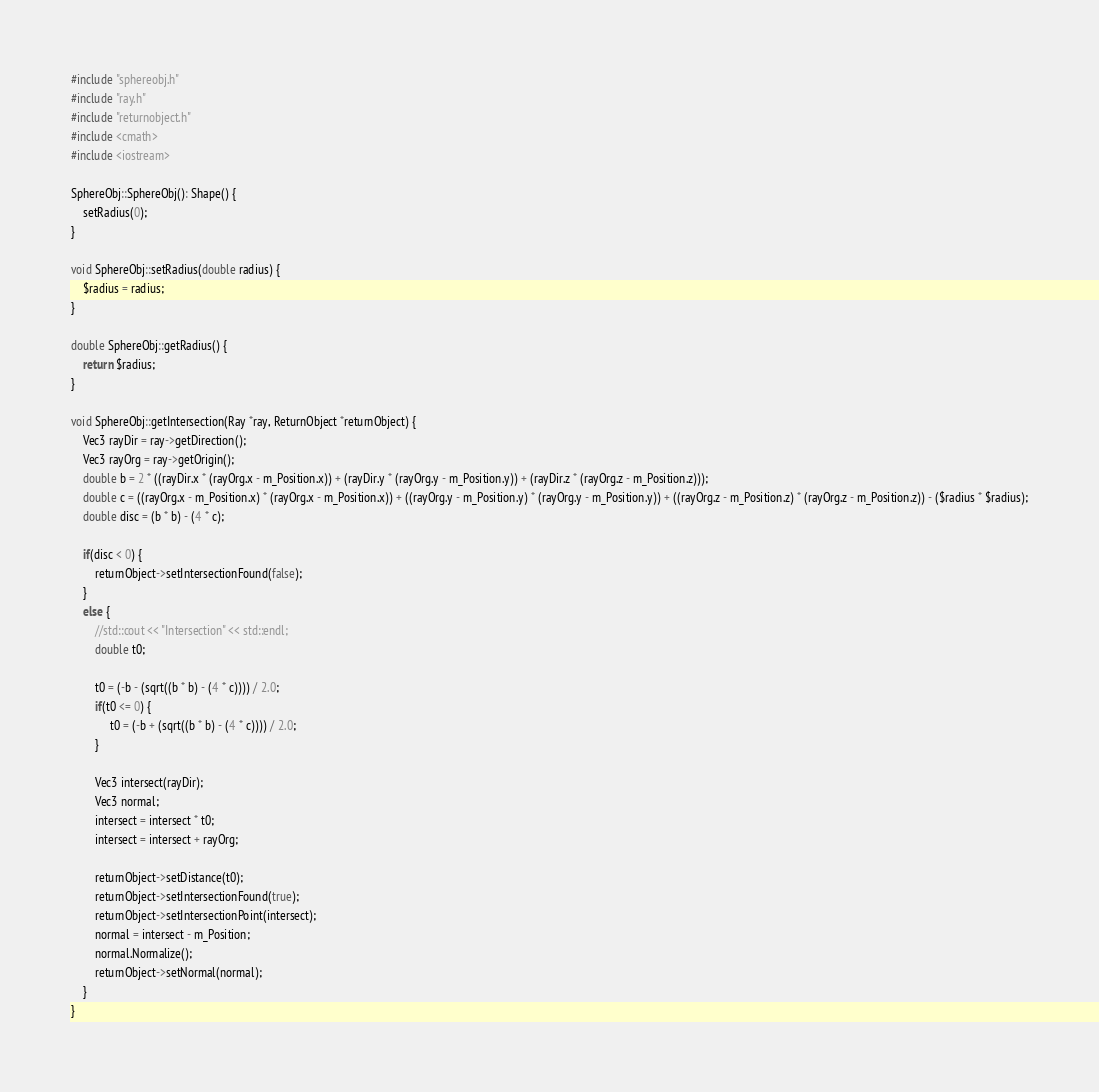Convert code to text. <code><loc_0><loc_0><loc_500><loc_500><_C++_>#include "sphereobj.h"
#include "ray.h"
#include "returnobject.h"
#include <cmath>
#include <iostream>

SphereObj::SphereObj(): Shape() {
    setRadius(0);
}

void SphereObj::setRadius(double radius) {
    $radius = radius;
}

double SphereObj::getRadius() {
    return $radius;
}

void SphereObj::getIntersection(Ray *ray, ReturnObject *returnObject) {
    Vec3 rayDir = ray->getDirection();
    Vec3 rayOrg = ray->getOrigin();
    double b = 2 * ((rayDir.x * (rayOrg.x - m_Position.x)) + (rayDir.y * (rayOrg.y - m_Position.y)) + (rayDir.z * (rayOrg.z - m_Position.z)));
    double c = ((rayOrg.x - m_Position.x) * (rayOrg.x - m_Position.x)) + ((rayOrg.y - m_Position.y) * (rayOrg.y - m_Position.y)) + ((rayOrg.z - m_Position.z) * (rayOrg.z - m_Position.z)) - ($radius * $radius);
    double disc = (b * b) - (4 * c);

    if(disc < 0) {
        returnObject->setIntersectionFound(false);
    }
    else {
        //std::cout << "Intersection" << std::endl;
        double t0;

        t0 = (-b - (sqrt((b * b) - (4 * c)))) / 2.0;
        if(t0 <= 0) {
             t0 = (-b + (sqrt((b * b) - (4 * c)))) / 2.0;
        }

        Vec3 intersect(rayDir);
        Vec3 normal;
        intersect = intersect * t0;
        intersect = intersect + rayOrg;

        returnObject->setDistance(t0);
        returnObject->setIntersectionFound(true);
        returnObject->setIntersectionPoint(intersect);
        normal = intersect - m_Position;
        normal.Normalize();
        returnObject->setNormal(normal);
    }
}
</code> 